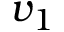<formula> <loc_0><loc_0><loc_500><loc_500>v _ { 1 }</formula> 